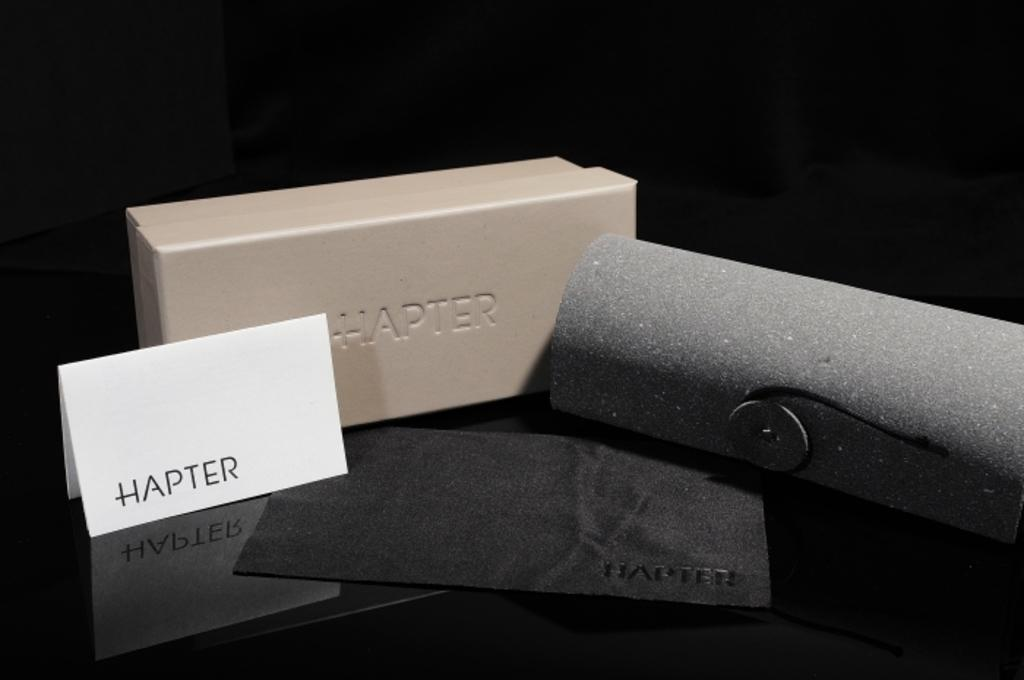<image>
Summarize the visual content of the image. a card that says 'hapter' in front of a box with the same word on it 